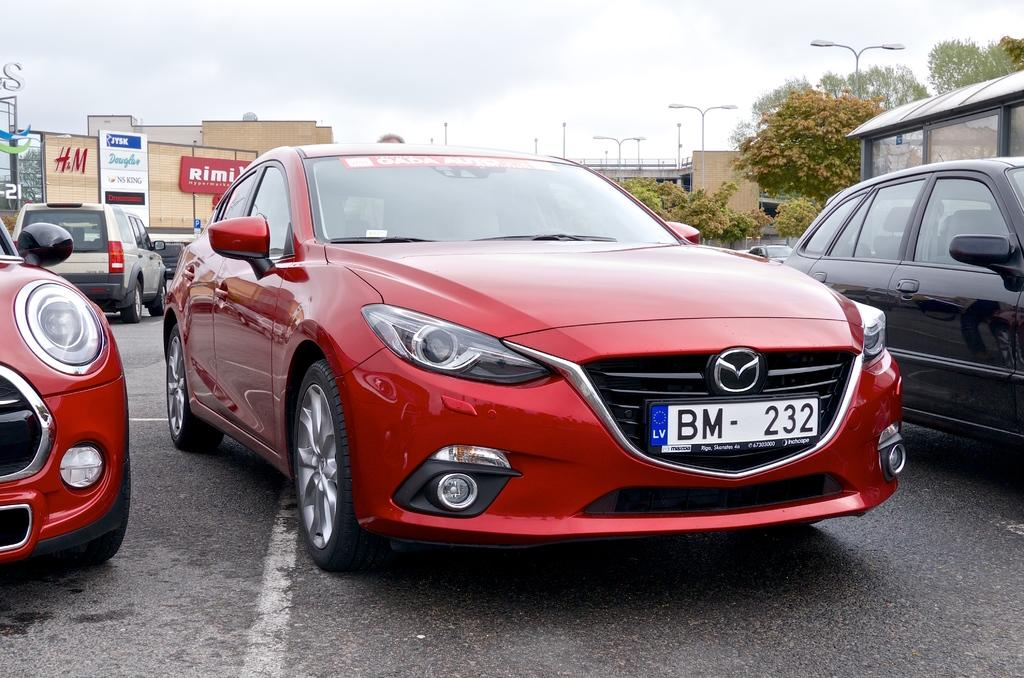What can be seen on the road in the image? Cars are parked on the road in the image. What is visible in the background of the image? There are buildings, trees, a street light, and the sky visible in the background. Can you describe the type of street light in the image? The street light is visible in the background, but no specific details about its type are provided. Reasoning: Let's think step by identifying the main subjects and objects in the image based on the provided facts. We then formulate questions that focus on the location and characteristics of these subjects and objects, ensuring that each question can be answered definitively with the information given. We avoid yes/no questions and ensure that the language is simple and clear. Absurd Question/Answer: What type of punishment is being handed out to the sock in the image? There is no sock present in the image, so no punishment can be observed. What type of beam is holding up the buildings in the image? The type of beam holding up the buildings is not visible in the image, as only the buildings themselves are mentioned. What type of punishment is being handed out to the sock in the image? There is no sock present in the image, so no punishment can be observed. What type of beam is holding up the buildings in the image? The type of beam holding up the buildings is not visible in the image, as only the buildings themselves are mentioned. 